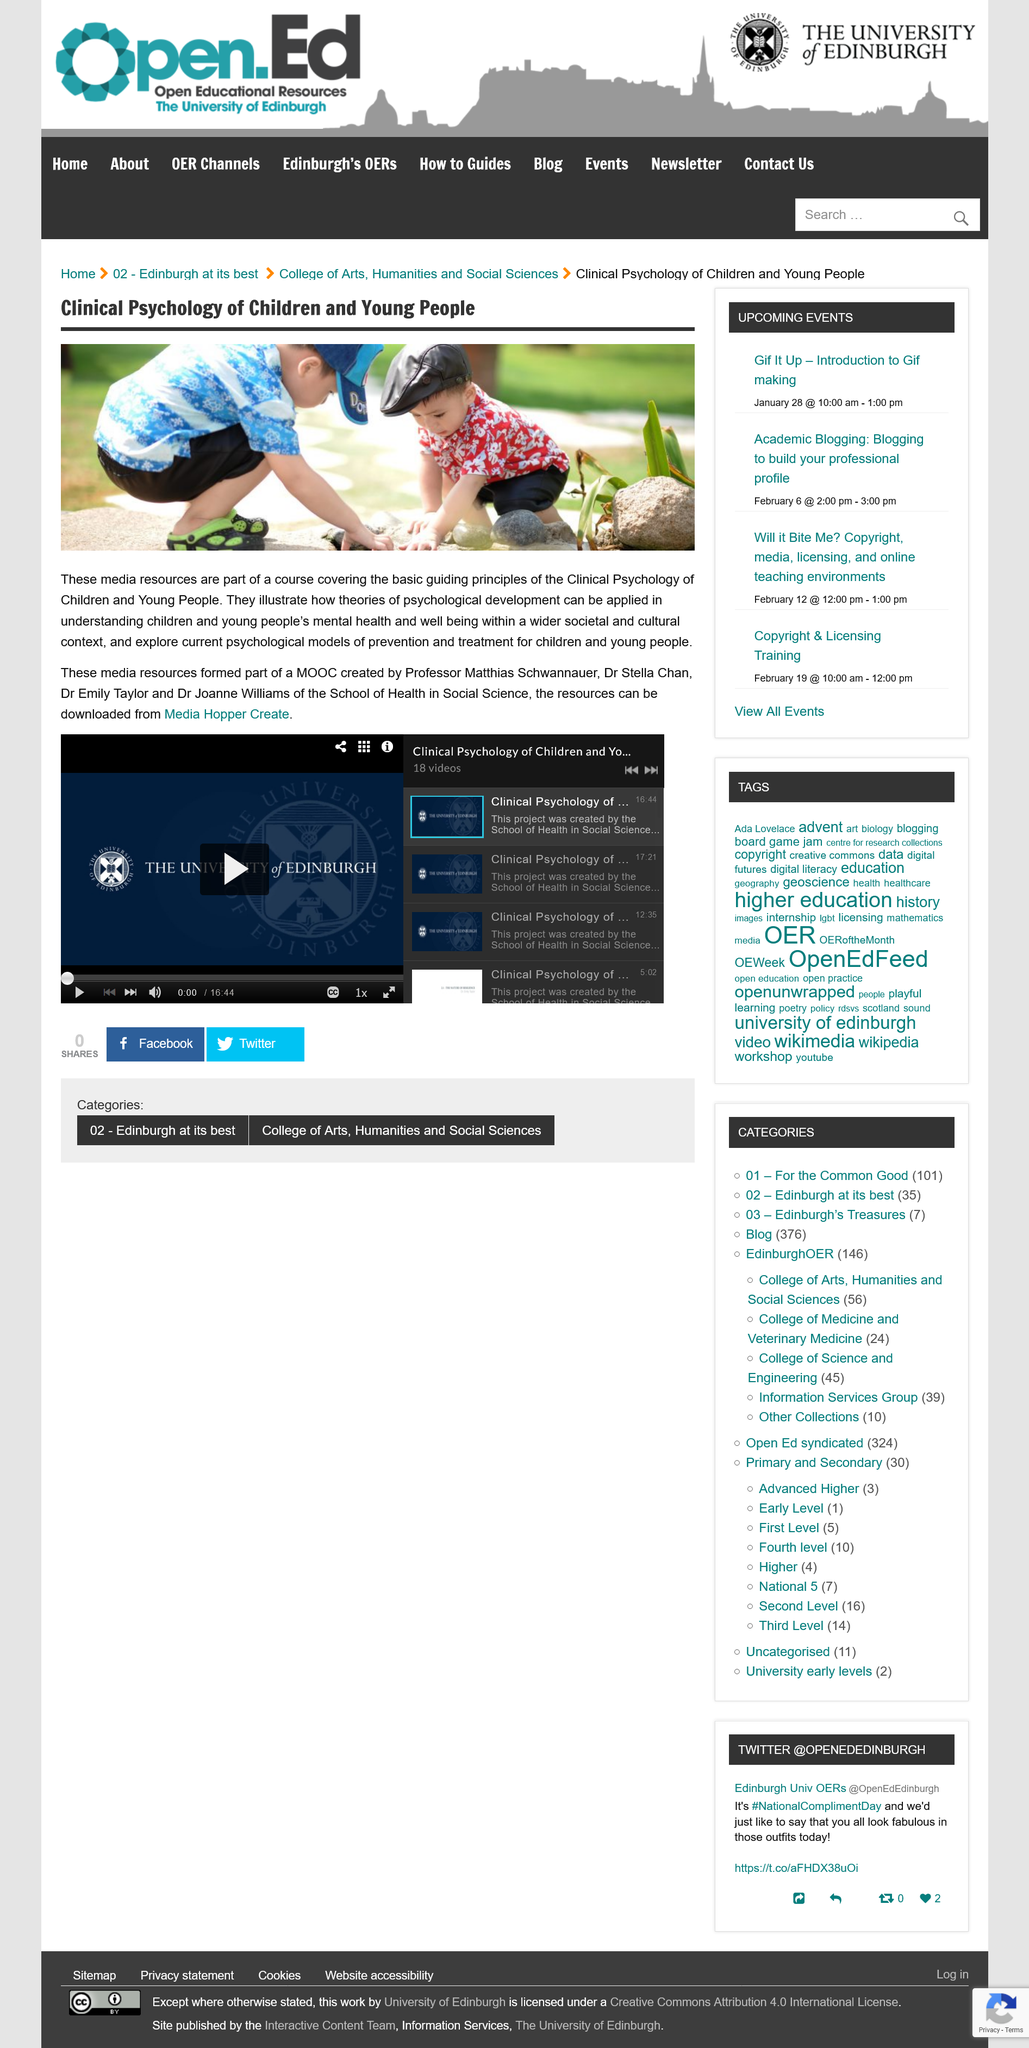Outline some significant characteristics in this image. Where can media resources illustrating the application of psychological development theories in understanding children's mental health be downloaded? They can be obtained from the Media Hopper Create. Stella Chan is one of the individuals who contributed to the creation of a MOOC. Emily Taylor is one of the individuals responsible for creating a MOOC. In fact, she is among the people who contributed to its development. 